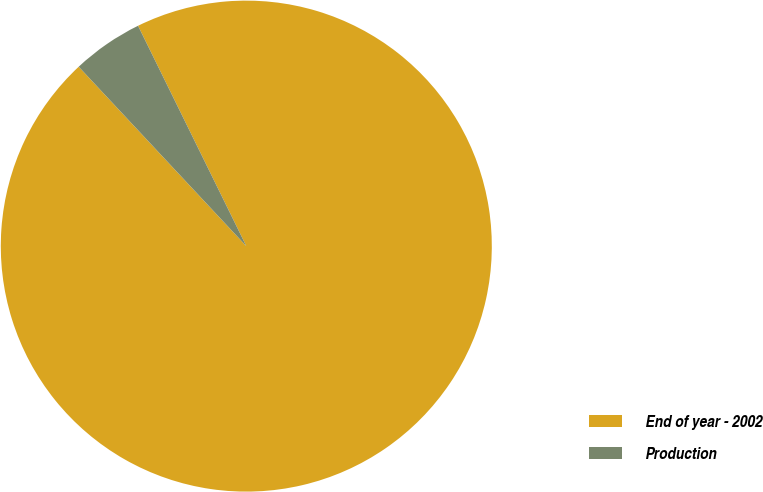Convert chart to OTSL. <chart><loc_0><loc_0><loc_500><loc_500><pie_chart><fcel>End of year - 2002<fcel>Production<nl><fcel>95.31%<fcel>4.69%<nl></chart> 